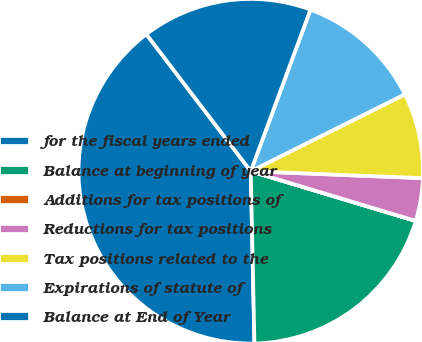Convert chart. <chart><loc_0><loc_0><loc_500><loc_500><pie_chart><fcel>for the fiscal years ended<fcel>Balance at beginning of year<fcel>Additions for tax positions of<fcel>Reductions for tax positions<fcel>Tax positions related to the<fcel>Expirations of statute of<fcel>Balance at End of Year<nl><fcel>39.98%<fcel>20.0%<fcel>0.01%<fcel>4.01%<fcel>8.01%<fcel>12.0%<fcel>16.0%<nl></chart> 